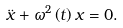<formula> <loc_0><loc_0><loc_500><loc_500>\ddot { x } + \omega ^ { 2 } \left ( t \right ) x = 0 .</formula> 